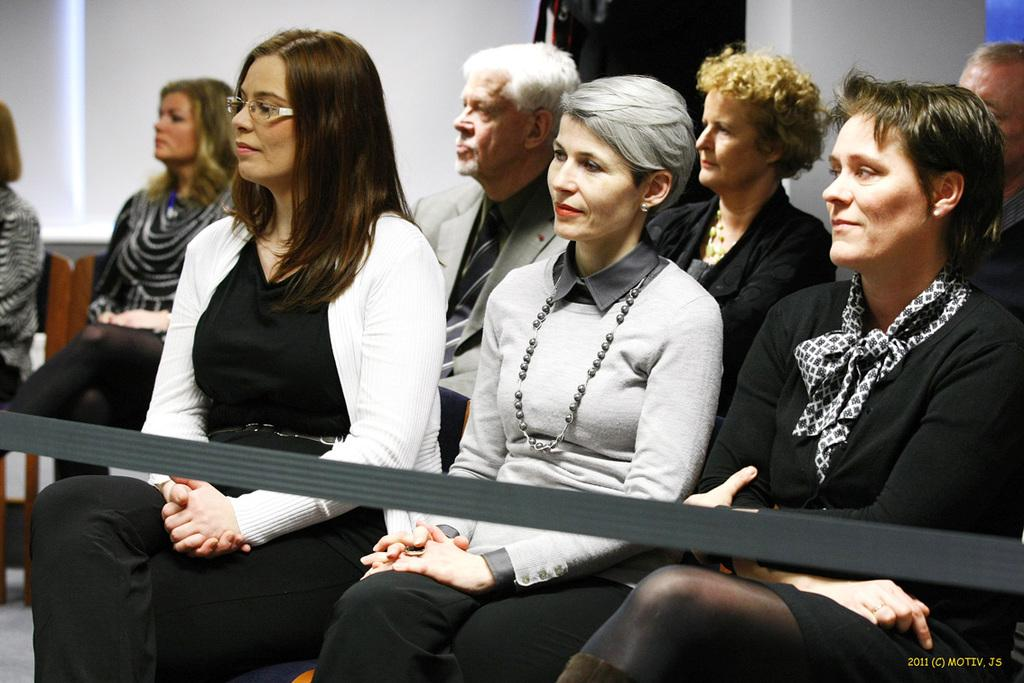What are the people in the image doing? The people in the image are sitting on chairs. What object can be seen in addition to the chairs and people? There is a rope visible in the image. What can be seen in the background of the image? There is a white color wall in the background of the image. How many cakes are being attempted to be balanced on the rope in the image? There are no cakes present in the image, nor is there any indication of an attempt to balance anything on the rope. 